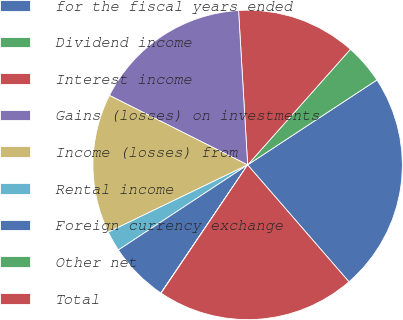Convert chart. <chart><loc_0><loc_0><loc_500><loc_500><pie_chart><fcel>for the fiscal years ended<fcel>Dividend income<fcel>Interest income<fcel>Gains (losses) on investments<fcel>Income (losses) from<fcel>Rental income<fcel>Foreign currency exchange<fcel>Other net<fcel>Total<nl><fcel>22.89%<fcel>4.18%<fcel>12.5%<fcel>16.65%<fcel>14.57%<fcel>2.11%<fcel>6.26%<fcel>0.03%<fcel>20.81%<nl></chart> 